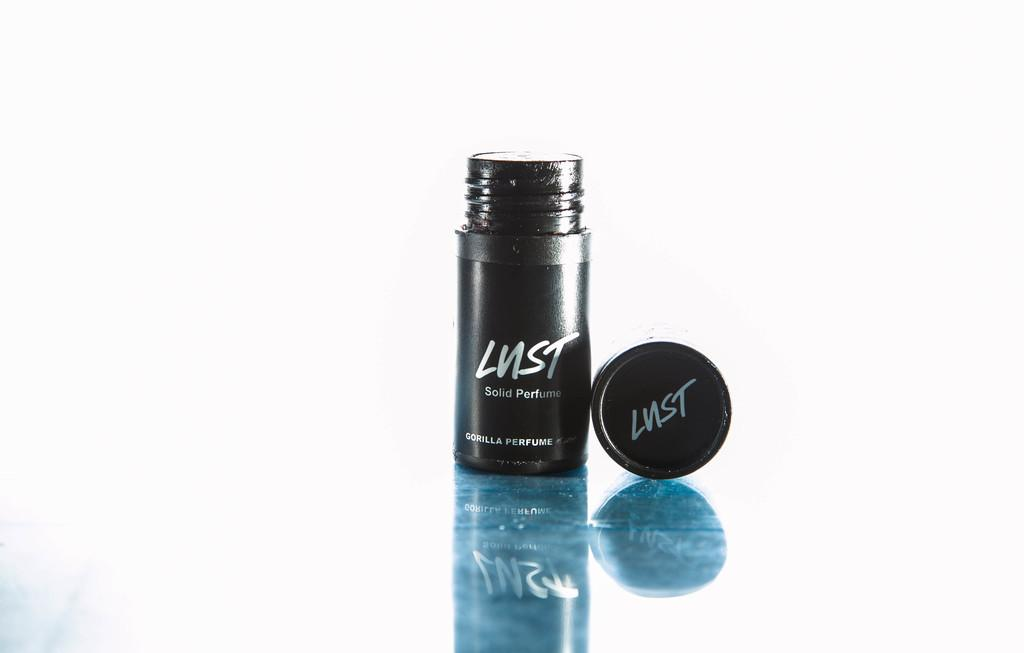<image>
Describe the image concisely. A small container of perfume is from the Lust brand. 